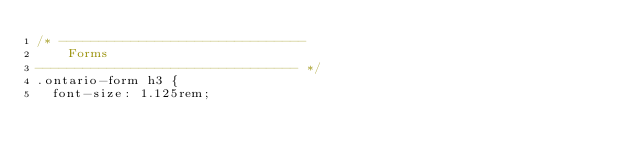<code> <loc_0><loc_0><loc_500><loc_500><_CSS_>/* -------------------------------
    Forms
--------------------------------- */
.ontario-form h3 {
  font-size: 1.125rem;</code> 